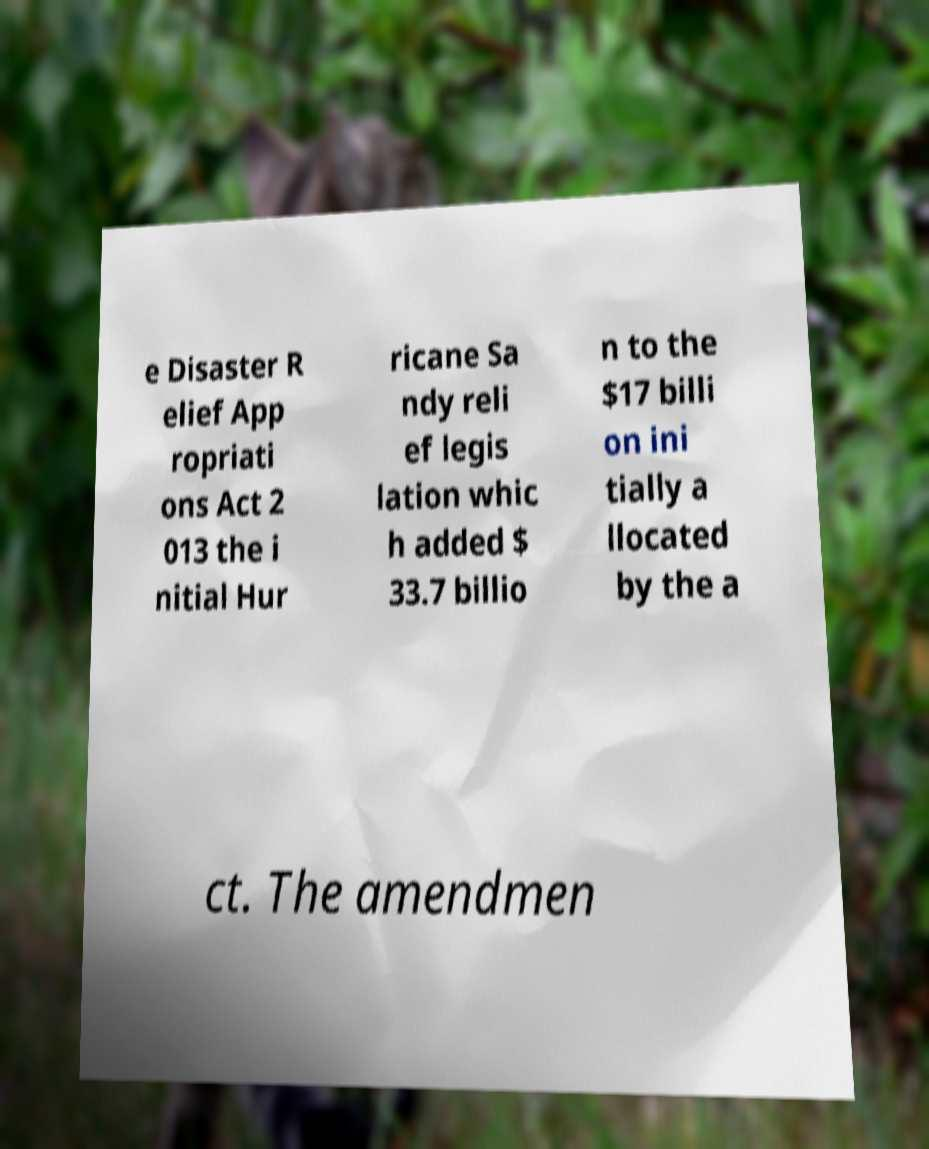I need the written content from this picture converted into text. Can you do that? e Disaster R elief App ropriati ons Act 2 013 the i nitial Hur ricane Sa ndy reli ef legis lation whic h added $ 33.7 billio n to the $17 billi on ini tially a llocated by the a ct. The amendmen 